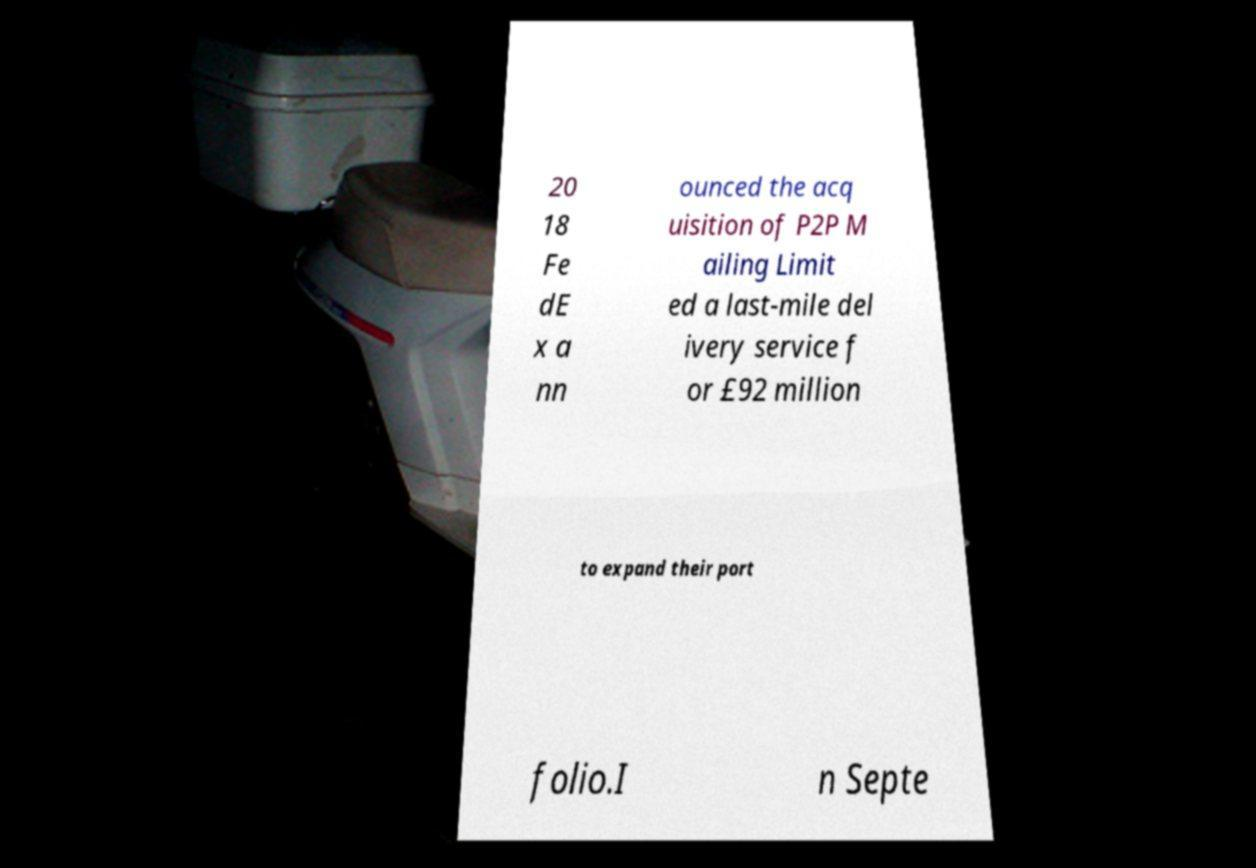There's text embedded in this image that I need extracted. Can you transcribe it verbatim? 20 18 Fe dE x a nn ounced the acq uisition of P2P M ailing Limit ed a last-mile del ivery service f or £92 million to expand their port folio.I n Septe 